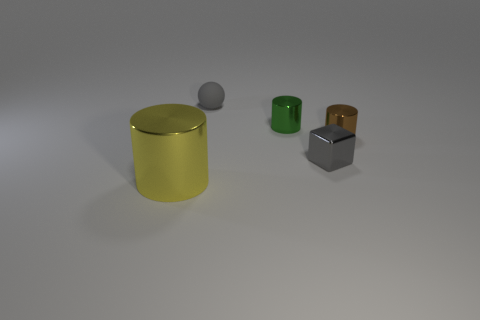Is there anything else that is the same shape as the gray metal object?
Keep it short and to the point. No. What number of shiny objects are small green objects or small cylinders?
Offer a very short reply. 2. There is a object that is to the left of the small green cylinder and behind the yellow metallic cylinder; what is its color?
Ensure brevity in your answer.  Gray. There is a gray thing that is to the left of the gray metallic object; is it the same size as the green metallic thing?
Offer a terse response. Yes. How many things are tiny metal cylinders that are behind the brown cylinder or gray shiny objects?
Offer a very short reply. 2. Are there any yellow cylinders of the same size as the sphere?
Your answer should be very brief. No. What material is the ball that is the same size as the brown shiny cylinder?
Ensure brevity in your answer.  Rubber. There is a object that is behind the brown shiny cylinder and in front of the gray matte ball; what is its shape?
Give a very brief answer. Cylinder. There is a tiny rubber object behind the green metal cylinder; what color is it?
Keep it short and to the point. Gray. What is the size of the thing that is in front of the gray matte object and behind the brown thing?
Provide a short and direct response. Small. 